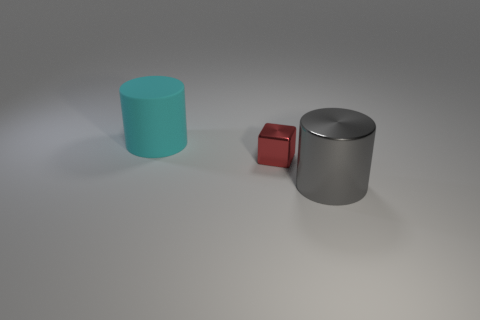Is there any other thing that has the same material as the cyan object?
Keep it short and to the point. No. There is a tiny thing that is made of the same material as the large gray cylinder; what shape is it?
Offer a very short reply. Cube. There is a object that is both in front of the cyan rubber cylinder and to the left of the gray shiny cylinder; what shape is it?
Offer a very short reply. Cube. Do the gray object and the red block have the same material?
Make the answer very short. Yes. What color is the object that is the same size as the cyan cylinder?
Provide a short and direct response. Gray. The object that is to the left of the large gray metal cylinder and in front of the cyan matte object is what color?
Ensure brevity in your answer.  Red. Are the large cyan cylinder and the cylinder that is in front of the tiny red metal object made of the same material?
Keep it short and to the point. No. There is a big rubber thing; is its shape the same as the large object in front of the red object?
Your answer should be very brief. Yes. What number of other things are there of the same material as the cyan object
Ensure brevity in your answer.  0. There is a large cylinder on the right side of the big thing behind the big cylinder that is in front of the big rubber cylinder; what is its color?
Your answer should be compact. Gray. 